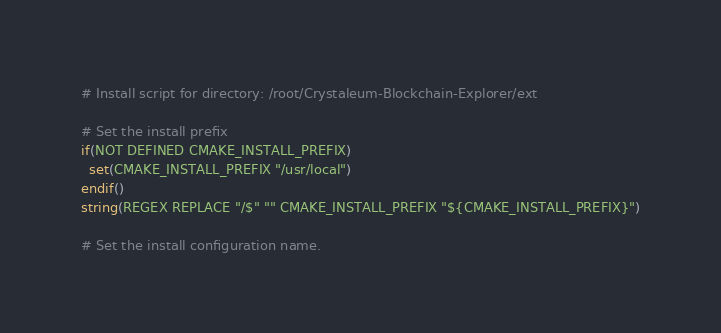Convert code to text. <code><loc_0><loc_0><loc_500><loc_500><_CMake_># Install script for directory: /root/Crystaleum-Blockchain-Explorer/ext

# Set the install prefix
if(NOT DEFINED CMAKE_INSTALL_PREFIX)
  set(CMAKE_INSTALL_PREFIX "/usr/local")
endif()
string(REGEX REPLACE "/$" "" CMAKE_INSTALL_PREFIX "${CMAKE_INSTALL_PREFIX}")

# Set the install configuration name.</code> 